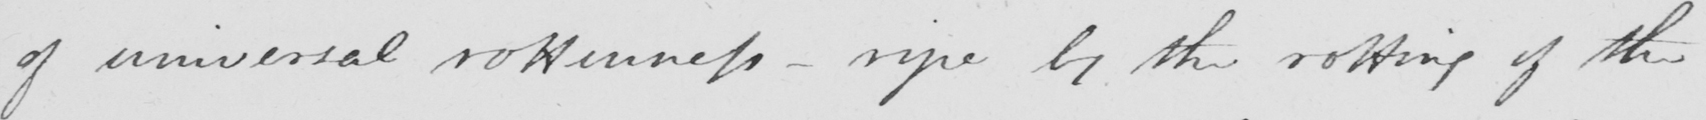Please transcribe the handwritten text in this image. of universal rottenness  _  ripe by the rotting of the 